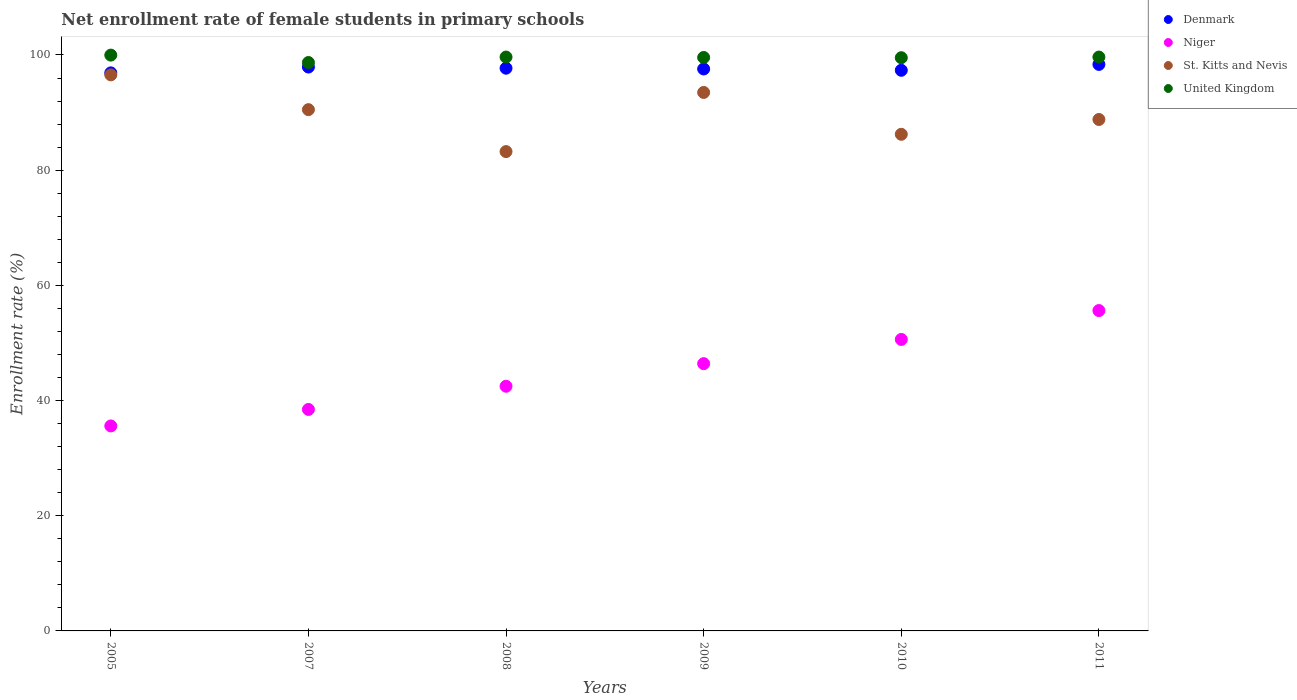Is the number of dotlines equal to the number of legend labels?
Offer a terse response. Yes. What is the net enrollment rate of female students in primary schools in St. Kitts and Nevis in 2011?
Your answer should be compact. 88.8. Across all years, what is the maximum net enrollment rate of female students in primary schools in St. Kitts and Nevis?
Keep it short and to the point. 96.55. Across all years, what is the minimum net enrollment rate of female students in primary schools in Denmark?
Your answer should be compact. 96.9. In which year was the net enrollment rate of female students in primary schools in St. Kitts and Nevis minimum?
Your response must be concise. 2008. What is the total net enrollment rate of female students in primary schools in Niger in the graph?
Keep it short and to the point. 269.17. What is the difference between the net enrollment rate of female students in primary schools in St. Kitts and Nevis in 2005 and that in 2008?
Provide a succinct answer. 13.32. What is the difference between the net enrollment rate of female students in primary schools in United Kingdom in 2011 and the net enrollment rate of female students in primary schools in Niger in 2005?
Ensure brevity in your answer.  64.05. What is the average net enrollment rate of female students in primary schools in Niger per year?
Give a very brief answer. 44.86. In the year 2007, what is the difference between the net enrollment rate of female students in primary schools in St. Kitts and Nevis and net enrollment rate of female students in primary schools in Denmark?
Provide a short and direct response. -7.4. What is the ratio of the net enrollment rate of female students in primary schools in United Kingdom in 2008 to that in 2009?
Give a very brief answer. 1. Is the difference between the net enrollment rate of female students in primary schools in St. Kitts and Nevis in 2005 and 2011 greater than the difference between the net enrollment rate of female students in primary schools in Denmark in 2005 and 2011?
Make the answer very short. Yes. What is the difference between the highest and the second highest net enrollment rate of female students in primary schools in Niger?
Make the answer very short. 5.01. What is the difference between the highest and the lowest net enrollment rate of female students in primary schools in Denmark?
Keep it short and to the point. 1.47. In how many years, is the net enrollment rate of female students in primary schools in Niger greater than the average net enrollment rate of female students in primary schools in Niger taken over all years?
Make the answer very short. 3. Is the sum of the net enrollment rate of female students in primary schools in St. Kitts and Nevis in 2005 and 2007 greater than the maximum net enrollment rate of female students in primary schools in Denmark across all years?
Provide a short and direct response. Yes. Is it the case that in every year, the sum of the net enrollment rate of female students in primary schools in St. Kitts and Nevis and net enrollment rate of female students in primary schools in Denmark  is greater than the sum of net enrollment rate of female students in primary schools in Niger and net enrollment rate of female students in primary schools in United Kingdom?
Your answer should be very brief. No. Is the net enrollment rate of female students in primary schools in St. Kitts and Nevis strictly less than the net enrollment rate of female students in primary schools in Denmark over the years?
Provide a succinct answer. Yes. How many years are there in the graph?
Offer a very short reply. 6. What is the difference between two consecutive major ticks on the Y-axis?
Make the answer very short. 20. Are the values on the major ticks of Y-axis written in scientific E-notation?
Give a very brief answer. No. Does the graph contain any zero values?
Give a very brief answer. No. Does the graph contain grids?
Offer a very short reply. No. Where does the legend appear in the graph?
Offer a very short reply. Top right. How are the legend labels stacked?
Make the answer very short. Vertical. What is the title of the graph?
Your answer should be very brief. Net enrollment rate of female students in primary schools. What is the label or title of the X-axis?
Give a very brief answer. Years. What is the label or title of the Y-axis?
Your response must be concise. Enrollment rate (%). What is the Enrollment rate (%) in Denmark in 2005?
Make the answer very short. 96.9. What is the Enrollment rate (%) of Niger in 2005?
Provide a short and direct response. 35.59. What is the Enrollment rate (%) of St. Kitts and Nevis in 2005?
Provide a short and direct response. 96.55. What is the Enrollment rate (%) in United Kingdom in 2005?
Your answer should be very brief. 99.98. What is the Enrollment rate (%) of Denmark in 2007?
Provide a short and direct response. 97.91. What is the Enrollment rate (%) in Niger in 2007?
Keep it short and to the point. 38.46. What is the Enrollment rate (%) in St. Kitts and Nevis in 2007?
Provide a short and direct response. 90.51. What is the Enrollment rate (%) in United Kingdom in 2007?
Keep it short and to the point. 98.69. What is the Enrollment rate (%) of Denmark in 2008?
Your answer should be very brief. 97.71. What is the Enrollment rate (%) in Niger in 2008?
Ensure brevity in your answer.  42.48. What is the Enrollment rate (%) in St. Kitts and Nevis in 2008?
Provide a succinct answer. 83.23. What is the Enrollment rate (%) in United Kingdom in 2008?
Give a very brief answer. 99.64. What is the Enrollment rate (%) of Denmark in 2009?
Ensure brevity in your answer.  97.57. What is the Enrollment rate (%) in Niger in 2009?
Your answer should be very brief. 46.4. What is the Enrollment rate (%) of St. Kitts and Nevis in 2009?
Your response must be concise. 93.5. What is the Enrollment rate (%) of United Kingdom in 2009?
Offer a terse response. 99.57. What is the Enrollment rate (%) in Denmark in 2010?
Provide a short and direct response. 97.34. What is the Enrollment rate (%) in Niger in 2010?
Your answer should be compact. 50.61. What is the Enrollment rate (%) of St. Kitts and Nevis in 2010?
Provide a short and direct response. 86.23. What is the Enrollment rate (%) in United Kingdom in 2010?
Ensure brevity in your answer.  99.53. What is the Enrollment rate (%) in Denmark in 2011?
Keep it short and to the point. 98.36. What is the Enrollment rate (%) in Niger in 2011?
Give a very brief answer. 55.62. What is the Enrollment rate (%) in St. Kitts and Nevis in 2011?
Your response must be concise. 88.8. What is the Enrollment rate (%) in United Kingdom in 2011?
Your answer should be very brief. 99.64. Across all years, what is the maximum Enrollment rate (%) in Denmark?
Offer a terse response. 98.36. Across all years, what is the maximum Enrollment rate (%) in Niger?
Your answer should be compact. 55.62. Across all years, what is the maximum Enrollment rate (%) in St. Kitts and Nevis?
Give a very brief answer. 96.55. Across all years, what is the maximum Enrollment rate (%) of United Kingdom?
Your answer should be compact. 99.98. Across all years, what is the minimum Enrollment rate (%) in Denmark?
Offer a very short reply. 96.9. Across all years, what is the minimum Enrollment rate (%) in Niger?
Ensure brevity in your answer.  35.59. Across all years, what is the minimum Enrollment rate (%) in St. Kitts and Nevis?
Keep it short and to the point. 83.23. Across all years, what is the minimum Enrollment rate (%) in United Kingdom?
Your answer should be very brief. 98.69. What is the total Enrollment rate (%) of Denmark in the graph?
Your answer should be very brief. 585.79. What is the total Enrollment rate (%) in Niger in the graph?
Your answer should be very brief. 269.17. What is the total Enrollment rate (%) in St. Kitts and Nevis in the graph?
Give a very brief answer. 538.81. What is the total Enrollment rate (%) of United Kingdom in the graph?
Offer a very short reply. 597.05. What is the difference between the Enrollment rate (%) of Denmark in 2005 and that in 2007?
Keep it short and to the point. -1.01. What is the difference between the Enrollment rate (%) in Niger in 2005 and that in 2007?
Ensure brevity in your answer.  -2.86. What is the difference between the Enrollment rate (%) in St. Kitts and Nevis in 2005 and that in 2007?
Ensure brevity in your answer.  6.04. What is the difference between the Enrollment rate (%) of United Kingdom in 2005 and that in 2007?
Offer a terse response. 1.28. What is the difference between the Enrollment rate (%) in Denmark in 2005 and that in 2008?
Make the answer very short. -0.81. What is the difference between the Enrollment rate (%) of Niger in 2005 and that in 2008?
Provide a short and direct response. -6.89. What is the difference between the Enrollment rate (%) in St. Kitts and Nevis in 2005 and that in 2008?
Provide a short and direct response. 13.32. What is the difference between the Enrollment rate (%) of United Kingdom in 2005 and that in 2008?
Your answer should be very brief. 0.34. What is the difference between the Enrollment rate (%) in Denmark in 2005 and that in 2009?
Your answer should be very brief. -0.68. What is the difference between the Enrollment rate (%) in Niger in 2005 and that in 2009?
Make the answer very short. -10.81. What is the difference between the Enrollment rate (%) of St. Kitts and Nevis in 2005 and that in 2009?
Ensure brevity in your answer.  3.05. What is the difference between the Enrollment rate (%) of United Kingdom in 2005 and that in 2009?
Offer a very short reply. 0.41. What is the difference between the Enrollment rate (%) of Denmark in 2005 and that in 2010?
Give a very brief answer. -0.45. What is the difference between the Enrollment rate (%) in Niger in 2005 and that in 2010?
Offer a terse response. -15.02. What is the difference between the Enrollment rate (%) in St. Kitts and Nevis in 2005 and that in 2010?
Give a very brief answer. 10.32. What is the difference between the Enrollment rate (%) of United Kingdom in 2005 and that in 2010?
Keep it short and to the point. 0.45. What is the difference between the Enrollment rate (%) of Denmark in 2005 and that in 2011?
Your response must be concise. -1.47. What is the difference between the Enrollment rate (%) in Niger in 2005 and that in 2011?
Provide a short and direct response. -20.03. What is the difference between the Enrollment rate (%) in St. Kitts and Nevis in 2005 and that in 2011?
Keep it short and to the point. 7.75. What is the difference between the Enrollment rate (%) in United Kingdom in 2005 and that in 2011?
Give a very brief answer. 0.34. What is the difference between the Enrollment rate (%) of Denmark in 2007 and that in 2008?
Your answer should be compact. 0.2. What is the difference between the Enrollment rate (%) of Niger in 2007 and that in 2008?
Provide a succinct answer. -4.03. What is the difference between the Enrollment rate (%) of St. Kitts and Nevis in 2007 and that in 2008?
Your answer should be very brief. 7.28. What is the difference between the Enrollment rate (%) in United Kingdom in 2007 and that in 2008?
Your answer should be compact. -0.95. What is the difference between the Enrollment rate (%) of Denmark in 2007 and that in 2009?
Your response must be concise. 0.33. What is the difference between the Enrollment rate (%) of Niger in 2007 and that in 2009?
Offer a very short reply. -7.95. What is the difference between the Enrollment rate (%) in St. Kitts and Nevis in 2007 and that in 2009?
Make the answer very short. -2.99. What is the difference between the Enrollment rate (%) in United Kingdom in 2007 and that in 2009?
Your answer should be very brief. -0.88. What is the difference between the Enrollment rate (%) in Denmark in 2007 and that in 2010?
Provide a short and direct response. 0.57. What is the difference between the Enrollment rate (%) in Niger in 2007 and that in 2010?
Make the answer very short. -12.16. What is the difference between the Enrollment rate (%) of St. Kitts and Nevis in 2007 and that in 2010?
Keep it short and to the point. 4.28. What is the difference between the Enrollment rate (%) of United Kingdom in 2007 and that in 2010?
Your answer should be compact. -0.83. What is the difference between the Enrollment rate (%) in Denmark in 2007 and that in 2011?
Offer a terse response. -0.46. What is the difference between the Enrollment rate (%) in Niger in 2007 and that in 2011?
Provide a succinct answer. -17.17. What is the difference between the Enrollment rate (%) of St. Kitts and Nevis in 2007 and that in 2011?
Make the answer very short. 1.71. What is the difference between the Enrollment rate (%) of United Kingdom in 2007 and that in 2011?
Keep it short and to the point. -0.95. What is the difference between the Enrollment rate (%) in Denmark in 2008 and that in 2009?
Ensure brevity in your answer.  0.13. What is the difference between the Enrollment rate (%) in Niger in 2008 and that in 2009?
Provide a succinct answer. -3.92. What is the difference between the Enrollment rate (%) in St. Kitts and Nevis in 2008 and that in 2009?
Offer a terse response. -10.27. What is the difference between the Enrollment rate (%) in United Kingdom in 2008 and that in 2009?
Your answer should be very brief. 0.07. What is the difference between the Enrollment rate (%) in Denmark in 2008 and that in 2010?
Make the answer very short. 0.36. What is the difference between the Enrollment rate (%) in Niger in 2008 and that in 2010?
Make the answer very short. -8.13. What is the difference between the Enrollment rate (%) in St. Kitts and Nevis in 2008 and that in 2010?
Provide a short and direct response. -3. What is the difference between the Enrollment rate (%) in United Kingdom in 2008 and that in 2010?
Keep it short and to the point. 0.11. What is the difference between the Enrollment rate (%) in Denmark in 2008 and that in 2011?
Give a very brief answer. -0.66. What is the difference between the Enrollment rate (%) in Niger in 2008 and that in 2011?
Your response must be concise. -13.14. What is the difference between the Enrollment rate (%) in St. Kitts and Nevis in 2008 and that in 2011?
Provide a short and direct response. -5.57. What is the difference between the Enrollment rate (%) in United Kingdom in 2008 and that in 2011?
Offer a very short reply. -0. What is the difference between the Enrollment rate (%) of Denmark in 2009 and that in 2010?
Your response must be concise. 0.23. What is the difference between the Enrollment rate (%) of Niger in 2009 and that in 2010?
Your answer should be very brief. -4.21. What is the difference between the Enrollment rate (%) in St. Kitts and Nevis in 2009 and that in 2010?
Your answer should be compact. 7.27. What is the difference between the Enrollment rate (%) in United Kingdom in 2009 and that in 2010?
Your answer should be compact. 0.04. What is the difference between the Enrollment rate (%) of Denmark in 2009 and that in 2011?
Provide a short and direct response. -0.79. What is the difference between the Enrollment rate (%) of Niger in 2009 and that in 2011?
Your answer should be compact. -9.22. What is the difference between the Enrollment rate (%) of St. Kitts and Nevis in 2009 and that in 2011?
Offer a very short reply. 4.7. What is the difference between the Enrollment rate (%) in United Kingdom in 2009 and that in 2011?
Your answer should be very brief. -0.07. What is the difference between the Enrollment rate (%) in Denmark in 2010 and that in 2011?
Provide a short and direct response. -1.02. What is the difference between the Enrollment rate (%) of Niger in 2010 and that in 2011?
Provide a succinct answer. -5.01. What is the difference between the Enrollment rate (%) of St. Kitts and Nevis in 2010 and that in 2011?
Make the answer very short. -2.57. What is the difference between the Enrollment rate (%) of United Kingdom in 2010 and that in 2011?
Give a very brief answer. -0.11. What is the difference between the Enrollment rate (%) in Denmark in 2005 and the Enrollment rate (%) in Niger in 2007?
Offer a terse response. 58.44. What is the difference between the Enrollment rate (%) in Denmark in 2005 and the Enrollment rate (%) in St. Kitts and Nevis in 2007?
Offer a terse response. 6.39. What is the difference between the Enrollment rate (%) of Denmark in 2005 and the Enrollment rate (%) of United Kingdom in 2007?
Provide a short and direct response. -1.8. What is the difference between the Enrollment rate (%) of Niger in 2005 and the Enrollment rate (%) of St. Kitts and Nevis in 2007?
Make the answer very short. -54.92. What is the difference between the Enrollment rate (%) in Niger in 2005 and the Enrollment rate (%) in United Kingdom in 2007?
Provide a short and direct response. -63.1. What is the difference between the Enrollment rate (%) of St. Kitts and Nevis in 2005 and the Enrollment rate (%) of United Kingdom in 2007?
Give a very brief answer. -2.14. What is the difference between the Enrollment rate (%) in Denmark in 2005 and the Enrollment rate (%) in Niger in 2008?
Your answer should be very brief. 54.41. What is the difference between the Enrollment rate (%) in Denmark in 2005 and the Enrollment rate (%) in St. Kitts and Nevis in 2008?
Make the answer very short. 13.67. What is the difference between the Enrollment rate (%) of Denmark in 2005 and the Enrollment rate (%) of United Kingdom in 2008?
Give a very brief answer. -2.74. What is the difference between the Enrollment rate (%) of Niger in 2005 and the Enrollment rate (%) of St. Kitts and Nevis in 2008?
Make the answer very short. -47.64. What is the difference between the Enrollment rate (%) in Niger in 2005 and the Enrollment rate (%) in United Kingdom in 2008?
Offer a very short reply. -64.05. What is the difference between the Enrollment rate (%) in St. Kitts and Nevis in 2005 and the Enrollment rate (%) in United Kingdom in 2008?
Offer a terse response. -3.09. What is the difference between the Enrollment rate (%) in Denmark in 2005 and the Enrollment rate (%) in Niger in 2009?
Offer a very short reply. 50.49. What is the difference between the Enrollment rate (%) in Denmark in 2005 and the Enrollment rate (%) in United Kingdom in 2009?
Provide a succinct answer. -2.67. What is the difference between the Enrollment rate (%) in Niger in 2005 and the Enrollment rate (%) in St. Kitts and Nevis in 2009?
Your response must be concise. -57.9. What is the difference between the Enrollment rate (%) of Niger in 2005 and the Enrollment rate (%) of United Kingdom in 2009?
Provide a succinct answer. -63.98. What is the difference between the Enrollment rate (%) of St. Kitts and Nevis in 2005 and the Enrollment rate (%) of United Kingdom in 2009?
Provide a succinct answer. -3.02. What is the difference between the Enrollment rate (%) in Denmark in 2005 and the Enrollment rate (%) in Niger in 2010?
Your answer should be very brief. 46.29. What is the difference between the Enrollment rate (%) in Denmark in 2005 and the Enrollment rate (%) in St. Kitts and Nevis in 2010?
Make the answer very short. 10.67. What is the difference between the Enrollment rate (%) in Denmark in 2005 and the Enrollment rate (%) in United Kingdom in 2010?
Provide a succinct answer. -2.63. What is the difference between the Enrollment rate (%) of Niger in 2005 and the Enrollment rate (%) of St. Kitts and Nevis in 2010?
Ensure brevity in your answer.  -50.64. What is the difference between the Enrollment rate (%) of Niger in 2005 and the Enrollment rate (%) of United Kingdom in 2010?
Your response must be concise. -63.93. What is the difference between the Enrollment rate (%) in St. Kitts and Nevis in 2005 and the Enrollment rate (%) in United Kingdom in 2010?
Offer a very short reply. -2.98. What is the difference between the Enrollment rate (%) of Denmark in 2005 and the Enrollment rate (%) of Niger in 2011?
Make the answer very short. 41.27. What is the difference between the Enrollment rate (%) of Denmark in 2005 and the Enrollment rate (%) of St. Kitts and Nevis in 2011?
Offer a terse response. 8.1. What is the difference between the Enrollment rate (%) of Denmark in 2005 and the Enrollment rate (%) of United Kingdom in 2011?
Offer a very short reply. -2.74. What is the difference between the Enrollment rate (%) in Niger in 2005 and the Enrollment rate (%) in St. Kitts and Nevis in 2011?
Make the answer very short. -53.21. What is the difference between the Enrollment rate (%) of Niger in 2005 and the Enrollment rate (%) of United Kingdom in 2011?
Offer a very short reply. -64.05. What is the difference between the Enrollment rate (%) in St. Kitts and Nevis in 2005 and the Enrollment rate (%) in United Kingdom in 2011?
Keep it short and to the point. -3.09. What is the difference between the Enrollment rate (%) in Denmark in 2007 and the Enrollment rate (%) in Niger in 2008?
Make the answer very short. 55.42. What is the difference between the Enrollment rate (%) of Denmark in 2007 and the Enrollment rate (%) of St. Kitts and Nevis in 2008?
Keep it short and to the point. 14.68. What is the difference between the Enrollment rate (%) in Denmark in 2007 and the Enrollment rate (%) in United Kingdom in 2008?
Provide a succinct answer. -1.73. What is the difference between the Enrollment rate (%) in Niger in 2007 and the Enrollment rate (%) in St. Kitts and Nevis in 2008?
Your answer should be very brief. -44.77. What is the difference between the Enrollment rate (%) of Niger in 2007 and the Enrollment rate (%) of United Kingdom in 2008?
Your answer should be very brief. -61.19. What is the difference between the Enrollment rate (%) of St. Kitts and Nevis in 2007 and the Enrollment rate (%) of United Kingdom in 2008?
Ensure brevity in your answer.  -9.13. What is the difference between the Enrollment rate (%) of Denmark in 2007 and the Enrollment rate (%) of Niger in 2009?
Your answer should be very brief. 51.5. What is the difference between the Enrollment rate (%) in Denmark in 2007 and the Enrollment rate (%) in St. Kitts and Nevis in 2009?
Your answer should be very brief. 4.41. What is the difference between the Enrollment rate (%) in Denmark in 2007 and the Enrollment rate (%) in United Kingdom in 2009?
Make the answer very short. -1.66. What is the difference between the Enrollment rate (%) in Niger in 2007 and the Enrollment rate (%) in St. Kitts and Nevis in 2009?
Ensure brevity in your answer.  -55.04. What is the difference between the Enrollment rate (%) in Niger in 2007 and the Enrollment rate (%) in United Kingdom in 2009?
Make the answer very short. -61.12. What is the difference between the Enrollment rate (%) in St. Kitts and Nevis in 2007 and the Enrollment rate (%) in United Kingdom in 2009?
Offer a very short reply. -9.06. What is the difference between the Enrollment rate (%) of Denmark in 2007 and the Enrollment rate (%) of Niger in 2010?
Your response must be concise. 47.3. What is the difference between the Enrollment rate (%) of Denmark in 2007 and the Enrollment rate (%) of St. Kitts and Nevis in 2010?
Provide a succinct answer. 11.68. What is the difference between the Enrollment rate (%) in Denmark in 2007 and the Enrollment rate (%) in United Kingdom in 2010?
Provide a succinct answer. -1.62. What is the difference between the Enrollment rate (%) in Niger in 2007 and the Enrollment rate (%) in St. Kitts and Nevis in 2010?
Offer a terse response. -47.77. What is the difference between the Enrollment rate (%) of Niger in 2007 and the Enrollment rate (%) of United Kingdom in 2010?
Provide a short and direct response. -61.07. What is the difference between the Enrollment rate (%) of St. Kitts and Nevis in 2007 and the Enrollment rate (%) of United Kingdom in 2010?
Offer a very short reply. -9.02. What is the difference between the Enrollment rate (%) in Denmark in 2007 and the Enrollment rate (%) in Niger in 2011?
Keep it short and to the point. 42.28. What is the difference between the Enrollment rate (%) of Denmark in 2007 and the Enrollment rate (%) of St. Kitts and Nevis in 2011?
Offer a terse response. 9.11. What is the difference between the Enrollment rate (%) in Denmark in 2007 and the Enrollment rate (%) in United Kingdom in 2011?
Provide a succinct answer. -1.73. What is the difference between the Enrollment rate (%) of Niger in 2007 and the Enrollment rate (%) of St. Kitts and Nevis in 2011?
Your answer should be very brief. -50.35. What is the difference between the Enrollment rate (%) in Niger in 2007 and the Enrollment rate (%) in United Kingdom in 2011?
Your answer should be very brief. -61.19. What is the difference between the Enrollment rate (%) of St. Kitts and Nevis in 2007 and the Enrollment rate (%) of United Kingdom in 2011?
Offer a very short reply. -9.13. What is the difference between the Enrollment rate (%) in Denmark in 2008 and the Enrollment rate (%) in Niger in 2009?
Your response must be concise. 51.3. What is the difference between the Enrollment rate (%) of Denmark in 2008 and the Enrollment rate (%) of St. Kitts and Nevis in 2009?
Ensure brevity in your answer.  4.21. What is the difference between the Enrollment rate (%) in Denmark in 2008 and the Enrollment rate (%) in United Kingdom in 2009?
Ensure brevity in your answer.  -1.87. What is the difference between the Enrollment rate (%) in Niger in 2008 and the Enrollment rate (%) in St. Kitts and Nevis in 2009?
Keep it short and to the point. -51.01. What is the difference between the Enrollment rate (%) in Niger in 2008 and the Enrollment rate (%) in United Kingdom in 2009?
Your answer should be compact. -57.09. What is the difference between the Enrollment rate (%) in St. Kitts and Nevis in 2008 and the Enrollment rate (%) in United Kingdom in 2009?
Ensure brevity in your answer.  -16.34. What is the difference between the Enrollment rate (%) in Denmark in 2008 and the Enrollment rate (%) in Niger in 2010?
Give a very brief answer. 47.09. What is the difference between the Enrollment rate (%) in Denmark in 2008 and the Enrollment rate (%) in St. Kitts and Nevis in 2010?
Your answer should be very brief. 11.48. What is the difference between the Enrollment rate (%) of Denmark in 2008 and the Enrollment rate (%) of United Kingdom in 2010?
Your response must be concise. -1.82. What is the difference between the Enrollment rate (%) of Niger in 2008 and the Enrollment rate (%) of St. Kitts and Nevis in 2010?
Give a very brief answer. -43.75. What is the difference between the Enrollment rate (%) of Niger in 2008 and the Enrollment rate (%) of United Kingdom in 2010?
Keep it short and to the point. -57.04. What is the difference between the Enrollment rate (%) of St. Kitts and Nevis in 2008 and the Enrollment rate (%) of United Kingdom in 2010?
Give a very brief answer. -16.3. What is the difference between the Enrollment rate (%) in Denmark in 2008 and the Enrollment rate (%) in Niger in 2011?
Make the answer very short. 42.08. What is the difference between the Enrollment rate (%) of Denmark in 2008 and the Enrollment rate (%) of St. Kitts and Nevis in 2011?
Make the answer very short. 8.9. What is the difference between the Enrollment rate (%) of Denmark in 2008 and the Enrollment rate (%) of United Kingdom in 2011?
Your answer should be compact. -1.94. What is the difference between the Enrollment rate (%) in Niger in 2008 and the Enrollment rate (%) in St. Kitts and Nevis in 2011?
Offer a very short reply. -46.32. What is the difference between the Enrollment rate (%) of Niger in 2008 and the Enrollment rate (%) of United Kingdom in 2011?
Your answer should be compact. -57.16. What is the difference between the Enrollment rate (%) in St. Kitts and Nevis in 2008 and the Enrollment rate (%) in United Kingdom in 2011?
Offer a terse response. -16.41. What is the difference between the Enrollment rate (%) in Denmark in 2009 and the Enrollment rate (%) in Niger in 2010?
Provide a succinct answer. 46.96. What is the difference between the Enrollment rate (%) of Denmark in 2009 and the Enrollment rate (%) of St. Kitts and Nevis in 2010?
Your answer should be compact. 11.35. What is the difference between the Enrollment rate (%) of Denmark in 2009 and the Enrollment rate (%) of United Kingdom in 2010?
Make the answer very short. -1.95. What is the difference between the Enrollment rate (%) in Niger in 2009 and the Enrollment rate (%) in St. Kitts and Nevis in 2010?
Provide a succinct answer. -39.82. What is the difference between the Enrollment rate (%) of Niger in 2009 and the Enrollment rate (%) of United Kingdom in 2010?
Your answer should be compact. -53.12. What is the difference between the Enrollment rate (%) of St. Kitts and Nevis in 2009 and the Enrollment rate (%) of United Kingdom in 2010?
Your response must be concise. -6.03. What is the difference between the Enrollment rate (%) of Denmark in 2009 and the Enrollment rate (%) of Niger in 2011?
Give a very brief answer. 41.95. What is the difference between the Enrollment rate (%) in Denmark in 2009 and the Enrollment rate (%) in St. Kitts and Nevis in 2011?
Make the answer very short. 8.77. What is the difference between the Enrollment rate (%) in Denmark in 2009 and the Enrollment rate (%) in United Kingdom in 2011?
Offer a terse response. -2.07. What is the difference between the Enrollment rate (%) of Niger in 2009 and the Enrollment rate (%) of St. Kitts and Nevis in 2011?
Your answer should be compact. -42.4. What is the difference between the Enrollment rate (%) in Niger in 2009 and the Enrollment rate (%) in United Kingdom in 2011?
Give a very brief answer. -53.24. What is the difference between the Enrollment rate (%) of St. Kitts and Nevis in 2009 and the Enrollment rate (%) of United Kingdom in 2011?
Give a very brief answer. -6.14. What is the difference between the Enrollment rate (%) of Denmark in 2010 and the Enrollment rate (%) of Niger in 2011?
Your answer should be compact. 41.72. What is the difference between the Enrollment rate (%) of Denmark in 2010 and the Enrollment rate (%) of St. Kitts and Nevis in 2011?
Your answer should be compact. 8.54. What is the difference between the Enrollment rate (%) in Denmark in 2010 and the Enrollment rate (%) in United Kingdom in 2011?
Your answer should be very brief. -2.3. What is the difference between the Enrollment rate (%) in Niger in 2010 and the Enrollment rate (%) in St. Kitts and Nevis in 2011?
Offer a very short reply. -38.19. What is the difference between the Enrollment rate (%) of Niger in 2010 and the Enrollment rate (%) of United Kingdom in 2011?
Provide a succinct answer. -49.03. What is the difference between the Enrollment rate (%) of St. Kitts and Nevis in 2010 and the Enrollment rate (%) of United Kingdom in 2011?
Your answer should be compact. -13.41. What is the average Enrollment rate (%) in Denmark per year?
Give a very brief answer. 97.63. What is the average Enrollment rate (%) of Niger per year?
Provide a short and direct response. 44.86. What is the average Enrollment rate (%) in St. Kitts and Nevis per year?
Give a very brief answer. 89.8. What is the average Enrollment rate (%) in United Kingdom per year?
Provide a short and direct response. 99.51. In the year 2005, what is the difference between the Enrollment rate (%) of Denmark and Enrollment rate (%) of Niger?
Offer a very short reply. 61.3. In the year 2005, what is the difference between the Enrollment rate (%) in Denmark and Enrollment rate (%) in St. Kitts and Nevis?
Offer a very short reply. 0.35. In the year 2005, what is the difference between the Enrollment rate (%) of Denmark and Enrollment rate (%) of United Kingdom?
Give a very brief answer. -3.08. In the year 2005, what is the difference between the Enrollment rate (%) in Niger and Enrollment rate (%) in St. Kitts and Nevis?
Offer a terse response. -60.96. In the year 2005, what is the difference between the Enrollment rate (%) of Niger and Enrollment rate (%) of United Kingdom?
Provide a short and direct response. -64.39. In the year 2005, what is the difference between the Enrollment rate (%) in St. Kitts and Nevis and Enrollment rate (%) in United Kingdom?
Provide a short and direct response. -3.43. In the year 2007, what is the difference between the Enrollment rate (%) in Denmark and Enrollment rate (%) in Niger?
Ensure brevity in your answer.  59.45. In the year 2007, what is the difference between the Enrollment rate (%) in Denmark and Enrollment rate (%) in St. Kitts and Nevis?
Your answer should be very brief. 7.4. In the year 2007, what is the difference between the Enrollment rate (%) of Denmark and Enrollment rate (%) of United Kingdom?
Offer a very short reply. -0.79. In the year 2007, what is the difference between the Enrollment rate (%) in Niger and Enrollment rate (%) in St. Kitts and Nevis?
Keep it short and to the point. -52.05. In the year 2007, what is the difference between the Enrollment rate (%) in Niger and Enrollment rate (%) in United Kingdom?
Make the answer very short. -60.24. In the year 2007, what is the difference between the Enrollment rate (%) in St. Kitts and Nevis and Enrollment rate (%) in United Kingdom?
Offer a very short reply. -8.18. In the year 2008, what is the difference between the Enrollment rate (%) of Denmark and Enrollment rate (%) of Niger?
Provide a short and direct response. 55.22. In the year 2008, what is the difference between the Enrollment rate (%) of Denmark and Enrollment rate (%) of St. Kitts and Nevis?
Provide a succinct answer. 14.48. In the year 2008, what is the difference between the Enrollment rate (%) in Denmark and Enrollment rate (%) in United Kingdom?
Offer a terse response. -1.94. In the year 2008, what is the difference between the Enrollment rate (%) of Niger and Enrollment rate (%) of St. Kitts and Nevis?
Provide a short and direct response. -40.74. In the year 2008, what is the difference between the Enrollment rate (%) in Niger and Enrollment rate (%) in United Kingdom?
Provide a short and direct response. -57.16. In the year 2008, what is the difference between the Enrollment rate (%) of St. Kitts and Nevis and Enrollment rate (%) of United Kingdom?
Offer a very short reply. -16.41. In the year 2009, what is the difference between the Enrollment rate (%) in Denmark and Enrollment rate (%) in Niger?
Your response must be concise. 51.17. In the year 2009, what is the difference between the Enrollment rate (%) in Denmark and Enrollment rate (%) in St. Kitts and Nevis?
Keep it short and to the point. 4.08. In the year 2009, what is the difference between the Enrollment rate (%) of Denmark and Enrollment rate (%) of United Kingdom?
Your answer should be compact. -2. In the year 2009, what is the difference between the Enrollment rate (%) in Niger and Enrollment rate (%) in St. Kitts and Nevis?
Your answer should be very brief. -47.09. In the year 2009, what is the difference between the Enrollment rate (%) in Niger and Enrollment rate (%) in United Kingdom?
Your answer should be compact. -53.17. In the year 2009, what is the difference between the Enrollment rate (%) in St. Kitts and Nevis and Enrollment rate (%) in United Kingdom?
Offer a terse response. -6.07. In the year 2010, what is the difference between the Enrollment rate (%) of Denmark and Enrollment rate (%) of Niger?
Your answer should be very brief. 46.73. In the year 2010, what is the difference between the Enrollment rate (%) in Denmark and Enrollment rate (%) in St. Kitts and Nevis?
Offer a terse response. 11.11. In the year 2010, what is the difference between the Enrollment rate (%) in Denmark and Enrollment rate (%) in United Kingdom?
Keep it short and to the point. -2.18. In the year 2010, what is the difference between the Enrollment rate (%) in Niger and Enrollment rate (%) in St. Kitts and Nevis?
Ensure brevity in your answer.  -35.62. In the year 2010, what is the difference between the Enrollment rate (%) of Niger and Enrollment rate (%) of United Kingdom?
Your answer should be very brief. -48.92. In the year 2010, what is the difference between the Enrollment rate (%) in St. Kitts and Nevis and Enrollment rate (%) in United Kingdom?
Make the answer very short. -13.3. In the year 2011, what is the difference between the Enrollment rate (%) in Denmark and Enrollment rate (%) in Niger?
Ensure brevity in your answer.  42.74. In the year 2011, what is the difference between the Enrollment rate (%) in Denmark and Enrollment rate (%) in St. Kitts and Nevis?
Make the answer very short. 9.56. In the year 2011, what is the difference between the Enrollment rate (%) of Denmark and Enrollment rate (%) of United Kingdom?
Provide a short and direct response. -1.28. In the year 2011, what is the difference between the Enrollment rate (%) in Niger and Enrollment rate (%) in St. Kitts and Nevis?
Offer a very short reply. -33.18. In the year 2011, what is the difference between the Enrollment rate (%) of Niger and Enrollment rate (%) of United Kingdom?
Your response must be concise. -44.02. In the year 2011, what is the difference between the Enrollment rate (%) of St. Kitts and Nevis and Enrollment rate (%) of United Kingdom?
Provide a short and direct response. -10.84. What is the ratio of the Enrollment rate (%) in Denmark in 2005 to that in 2007?
Offer a terse response. 0.99. What is the ratio of the Enrollment rate (%) in Niger in 2005 to that in 2007?
Provide a succinct answer. 0.93. What is the ratio of the Enrollment rate (%) in St. Kitts and Nevis in 2005 to that in 2007?
Your answer should be very brief. 1.07. What is the ratio of the Enrollment rate (%) of United Kingdom in 2005 to that in 2007?
Offer a terse response. 1.01. What is the ratio of the Enrollment rate (%) in Niger in 2005 to that in 2008?
Give a very brief answer. 0.84. What is the ratio of the Enrollment rate (%) in St. Kitts and Nevis in 2005 to that in 2008?
Provide a short and direct response. 1.16. What is the ratio of the Enrollment rate (%) in Niger in 2005 to that in 2009?
Offer a terse response. 0.77. What is the ratio of the Enrollment rate (%) of St. Kitts and Nevis in 2005 to that in 2009?
Ensure brevity in your answer.  1.03. What is the ratio of the Enrollment rate (%) in Niger in 2005 to that in 2010?
Provide a short and direct response. 0.7. What is the ratio of the Enrollment rate (%) in St. Kitts and Nevis in 2005 to that in 2010?
Make the answer very short. 1.12. What is the ratio of the Enrollment rate (%) in United Kingdom in 2005 to that in 2010?
Keep it short and to the point. 1. What is the ratio of the Enrollment rate (%) of Denmark in 2005 to that in 2011?
Ensure brevity in your answer.  0.99. What is the ratio of the Enrollment rate (%) of Niger in 2005 to that in 2011?
Give a very brief answer. 0.64. What is the ratio of the Enrollment rate (%) of St. Kitts and Nevis in 2005 to that in 2011?
Keep it short and to the point. 1.09. What is the ratio of the Enrollment rate (%) in Denmark in 2007 to that in 2008?
Your answer should be very brief. 1. What is the ratio of the Enrollment rate (%) in Niger in 2007 to that in 2008?
Ensure brevity in your answer.  0.91. What is the ratio of the Enrollment rate (%) of St. Kitts and Nevis in 2007 to that in 2008?
Your answer should be compact. 1.09. What is the ratio of the Enrollment rate (%) of United Kingdom in 2007 to that in 2008?
Your answer should be very brief. 0.99. What is the ratio of the Enrollment rate (%) of Niger in 2007 to that in 2009?
Your answer should be very brief. 0.83. What is the ratio of the Enrollment rate (%) in St. Kitts and Nevis in 2007 to that in 2009?
Offer a terse response. 0.97. What is the ratio of the Enrollment rate (%) in United Kingdom in 2007 to that in 2009?
Make the answer very short. 0.99. What is the ratio of the Enrollment rate (%) in Niger in 2007 to that in 2010?
Provide a succinct answer. 0.76. What is the ratio of the Enrollment rate (%) of St. Kitts and Nevis in 2007 to that in 2010?
Offer a terse response. 1.05. What is the ratio of the Enrollment rate (%) of Niger in 2007 to that in 2011?
Offer a terse response. 0.69. What is the ratio of the Enrollment rate (%) in St. Kitts and Nevis in 2007 to that in 2011?
Your response must be concise. 1.02. What is the ratio of the Enrollment rate (%) of Denmark in 2008 to that in 2009?
Offer a terse response. 1. What is the ratio of the Enrollment rate (%) in Niger in 2008 to that in 2009?
Your answer should be compact. 0.92. What is the ratio of the Enrollment rate (%) of St. Kitts and Nevis in 2008 to that in 2009?
Keep it short and to the point. 0.89. What is the ratio of the Enrollment rate (%) in Denmark in 2008 to that in 2010?
Give a very brief answer. 1. What is the ratio of the Enrollment rate (%) in Niger in 2008 to that in 2010?
Your response must be concise. 0.84. What is the ratio of the Enrollment rate (%) of St. Kitts and Nevis in 2008 to that in 2010?
Give a very brief answer. 0.97. What is the ratio of the Enrollment rate (%) of Denmark in 2008 to that in 2011?
Provide a succinct answer. 0.99. What is the ratio of the Enrollment rate (%) of Niger in 2008 to that in 2011?
Ensure brevity in your answer.  0.76. What is the ratio of the Enrollment rate (%) of St. Kitts and Nevis in 2008 to that in 2011?
Your answer should be compact. 0.94. What is the ratio of the Enrollment rate (%) of United Kingdom in 2008 to that in 2011?
Keep it short and to the point. 1. What is the ratio of the Enrollment rate (%) in Denmark in 2009 to that in 2010?
Offer a very short reply. 1. What is the ratio of the Enrollment rate (%) in Niger in 2009 to that in 2010?
Your answer should be compact. 0.92. What is the ratio of the Enrollment rate (%) of St. Kitts and Nevis in 2009 to that in 2010?
Provide a succinct answer. 1.08. What is the ratio of the Enrollment rate (%) of United Kingdom in 2009 to that in 2010?
Your answer should be very brief. 1. What is the ratio of the Enrollment rate (%) in Niger in 2009 to that in 2011?
Provide a succinct answer. 0.83. What is the ratio of the Enrollment rate (%) of St. Kitts and Nevis in 2009 to that in 2011?
Make the answer very short. 1.05. What is the ratio of the Enrollment rate (%) in Niger in 2010 to that in 2011?
Make the answer very short. 0.91. What is the ratio of the Enrollment rate (%) in United Kingdom in 2010 to that in 2011?
Make the answer very short. 1. What is the difference between the highest and the second highest Enrollment rate (%) of Denmark?
Your answer should be very brief. 0.46. What is the difference between the highest and the second highest Enrollment rate (%) in Niger?
Your answer should be compact. 5.01. What is the difference between the highest and the second highest Enrollment rate (%) in St. Kitts and Nevis?
Provide a succinct answer. 3.05. What is the difference between the highest and the second highest Enrollment rate (%) of United Kingdom?
Your answer should be very brief. 0.34. What is the difference between the highest and the lowest Enrollment rate (%) in Denmark?
Give a very brief answer. 1.47. What is the difference between the highest and the lowest Enrollment rate (%) in Niger?
Give a very brief answer. 20.03. What is the difference between the highest and the lowest Enrollment rate (%) in St. Kitts and Nevis?
Offer a very short reply. 13.32. What is the difference between the highest and the lowest Enrollment rate (%) of United Kingdom?
Offer a very short reply. 1.28. 